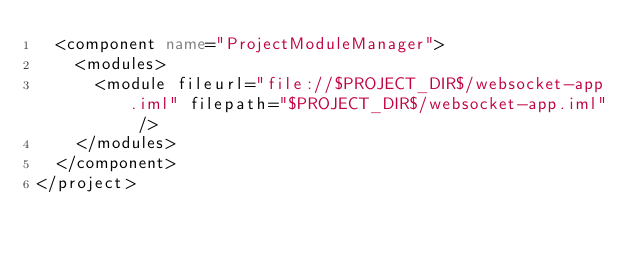<code> <loc_0><loc_0><loc_500><loc_500><_XML_>  <component name="ProjectModuleManager">
    <modules>
      <module fileurl="file://$PROJECT_DIR$/websocket-app.iml" filepath="$PROJECT_DIR$/websocket-app.iml" />
    </modules>
  </component>
</project></code> 